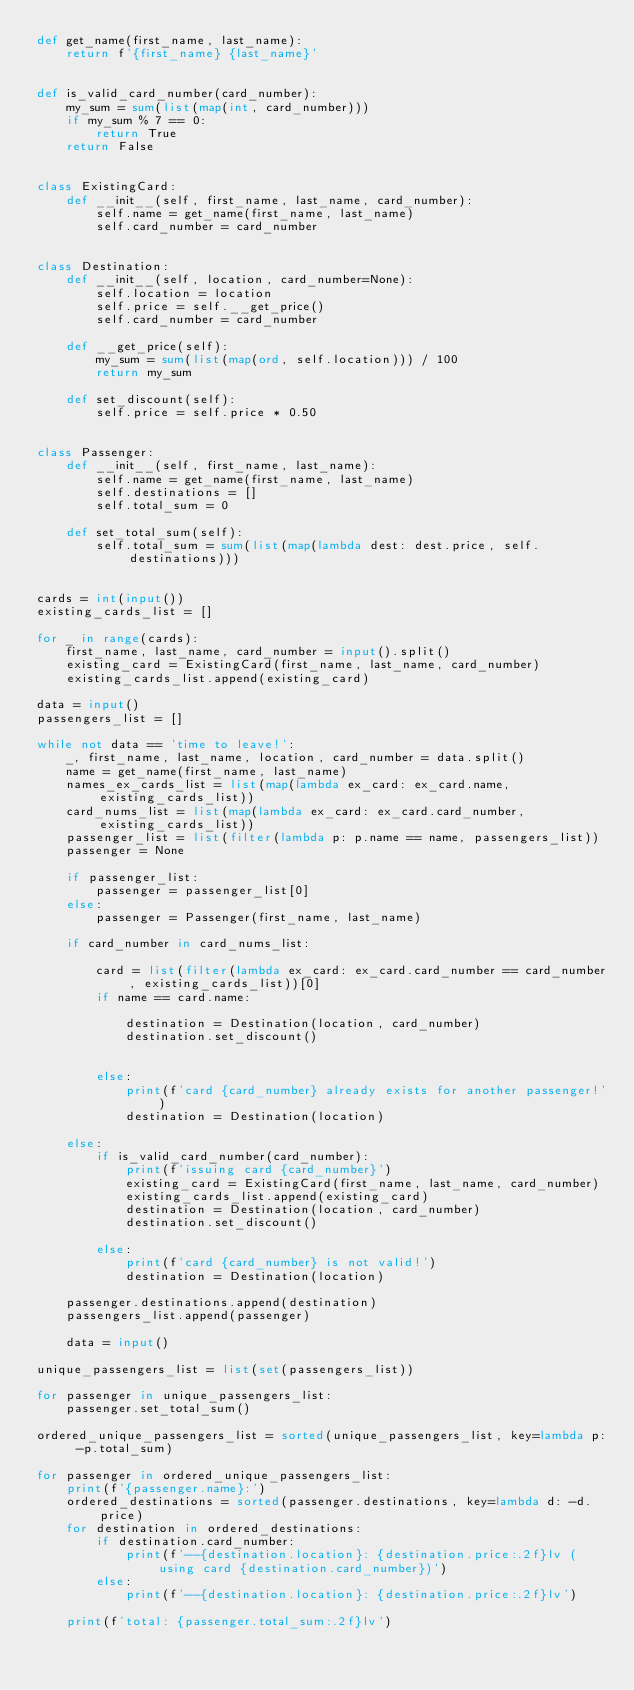Convert code to text. <code><loc_0><loc_0><loc_500><loc_500><_Python_>def get_name(first_name, last_name):
    return f'{first_name} {last_name}'


def is_valid_card_number(card_number):
    my_sum = sum(list(map(int, card_number)))
    if my_sum % 7 == 0:
        return True
    return False


class ExistingCard:
    def __init__(self, first_name, last_name, card_number):
        self.name = get_name(first_name, last_name)
        self.card_number = card_number


class Destination:
    def __init__(self, location, card_number=None):
        self.location = location
        self.price = self.__get_price()
        self.card_number = card_number

    def __get_price(self):
        my_sum = sum(list(map(ord, self.location))) / 100
        return my_sum

    def set_discount(self):
        self.price = self.price * 0.50


class Passenger:
    def __init__(self, first_name, last_name):
        self.name = get_name(first_name, last_name)
        self.destinations = []
        self.total_sum = 0

    def set_total_sum(self):
        self.total_sum = sum(list(map(lambda dest: dest.price, self.destinations)))


cards = int(input())
existing_cards_list = []

for _ in range(cards):
    first_name, last_name, card_number = input().split()
    existing_card = ExistingCard(first_name, last_name, card_number)
    existing_cards_list.append(existing_card)

data = input()
passengers_list = []

while not data == 'time to leave!':
    _, first_name, last_name, location, card_number = data.split()
    name = get_name(first_name, last_name)
    names_ex_cards_list = list(map(lambda ex_card: ex_card.name, existing_cards_list))
    card_nums_list = list(map(lambda ex_card: ex_card.card_number, existing_cards_list))
    passenger_list = list(filter(lambda p: p.name == name, passengers_list))
    passenger = None

    if passenger_list:
        passenger = passenger_list[0]
    else:
        passenger = Passenger(first_name, last_name)

    if card_number in card_nums_list:

        card = list(filter(lambda ex_card: ex_card.card_number == card_number, existing_cards_list))[0]
        if name == card.name:

            destination = Destination(location, card_number)
            destination.set_discount()


        else:
            print(f'card {card_number} already exists for another passenger!')
            destination = Destination(location)

    else:
        if is_valid_card_number(card_number):
            print(f'issuing card {card_number}')
            existing_card = ExistingCard(first_name, last_name, card_number)
            existing_cards_list.append(existing_card)
            destination = Destination(location, card_number)
            destination.set_discount()

        else:
            print(f'card {card_number} is not valid!')
            destination = Destination(location)

    passenger.destinations.append(destination)
    passengers_list.append(passenger)

    data = input()

unique_passengers_list = list(set(passengers_list))

for passenger in unique_passengers_list:
    passenger.set_total_sum()

ordered_unique_passengers_list = sorted(unique_passengers_list, key=lambda p: -p.total_sum)

for passenger in ordered_unique_passengers_list:
    print(f'{passenger.name}:')
    ordered_destinations = sorted(passenger.destinations, key=lambda d: -d.price)
    for destination in ordered_destinations:
        if destination.card_number:
            print(f'--{destination.location}: {destination.price:.2f}lv (using card {destination.card_number})')
        else:
            print(f'--{destination.location}: {destination.price:.2f}lv')

    print(f'total: {passenger.total_sum:.2f}lv')</code> 